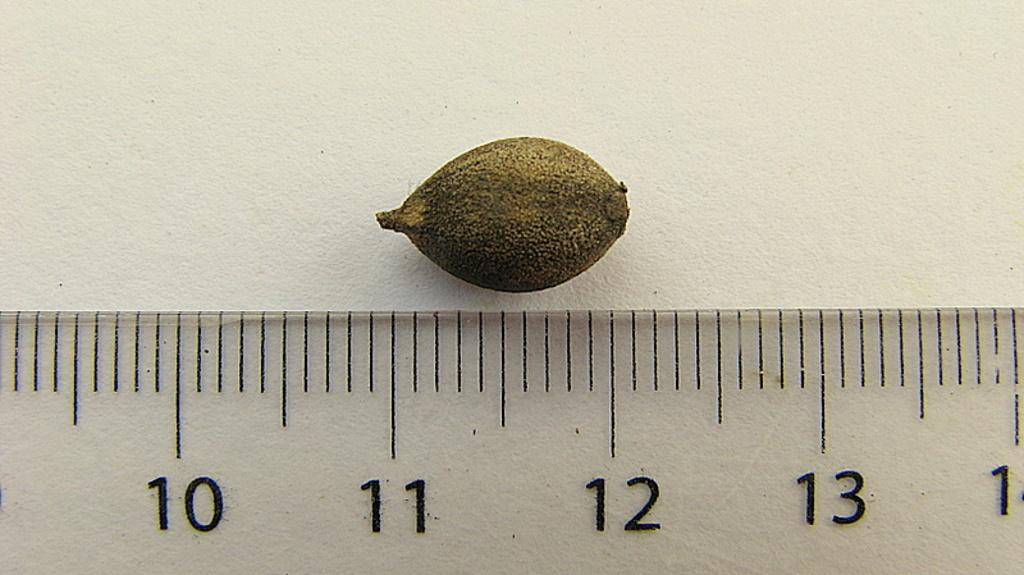<image>
Summarize the visual content of the image. a ruler that has the numbers 10 to 13 on it 